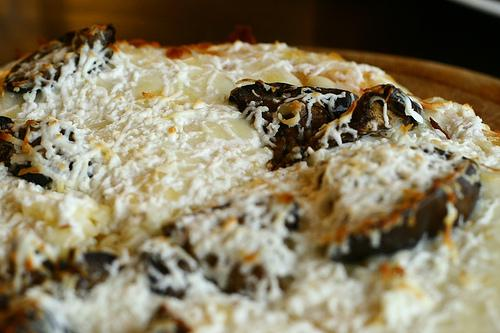Question: what is white?
Choices:
A. Bread.
B. Cheese.
C. Fruit.
D. Wine.
Answer with the letter. Answer: B Question: how many pizzas are there?
Choices:
A. Four.
B. Three.
C. One.
D. None.
Answer with the letter. Answer: C Question: what is on the plate?
Choices:
A. Pizza.
B. Tacos.
C. Pasta.
D. Salad.
Answer with the letter. Answer: A Question: why is it so bright?
Choices:
A. Lights are on.
B. Sun is out.
C. Moon is out.
D. Candles are lit.
Answer with the letter. Answer: A Question: where was the photo taken?
Choices:
A. Kitchen.
B. Restaraunt.
C. In a dining area.
D. Picnic table.
Answer with the letter. Answer: C 